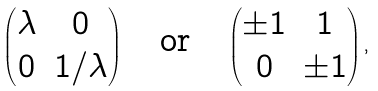<formula> <loc_0><loc_0><loc_500><loc_500>\begin{pmatrix} \lambda & 0 \\ 0 & 1 / \lambda \end{pmatrix} \quad \text {or} \quad \begin{pmatrix} \pm 1 & 1 \\ 0 & \pm 1 \end{pmatrix} ,</formula> 